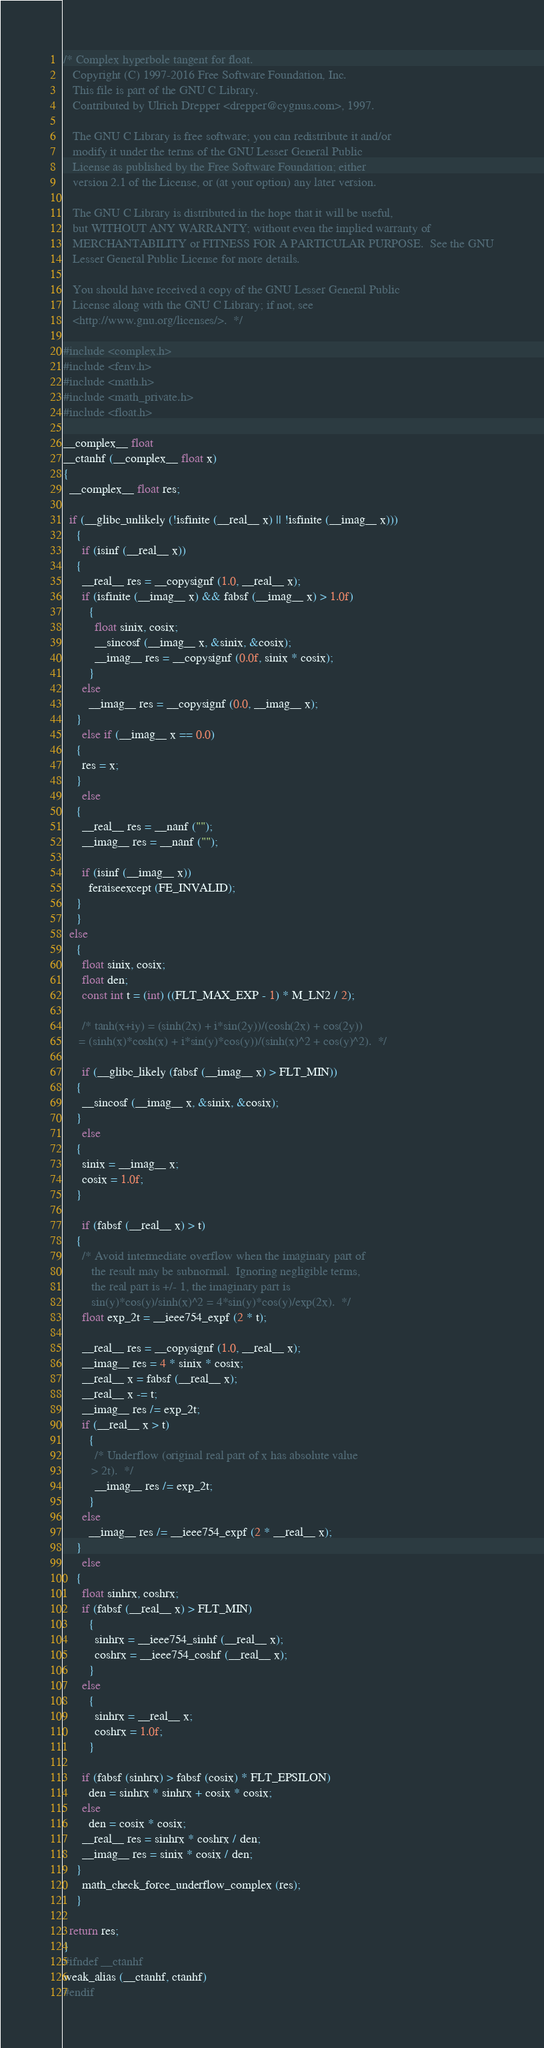Convert code to text. <code><loc_0><loc_0><loc_500><loc_500><_C_>/* Complex hyperbole tangent for float.
   Copyright (C) 1997-2016 Free Software Foundation, Inc.
   This file is part of the GNU C Library.
   Contributed by Ulrich Drepper <drepper@cygnus.com>, 1997.

   The GNU C Library is free software; you can redistribute it and/or
   modify it under the terms of the GNU Lesser General Public
   License as published by the Free Software Foundation; either
   version 2.1 of the License, or (at your option) any later version.

   The GNU C Library is distributed in the hope that it will be useful,
   but WITHOUT ANY WARRANTY; without even the implied warranty of
   MERCHANTABILITY or FITNESS FOR A PARTICULAR PURPOSE.  See the GNU
   Lesser General Public License for more details.

   You should have received a copy of the GNU Lesser General Public
   License along with the GNU C Library; if not, see
   <http://www.gnu.org/licenses/>.  */

#include <complex.h>
#include <fenv.h>
#include <math.h>
#include <math_private.h>
#include <float.h>

__complex__ float
__ctanhf (__complex__ float x)
{
  __complex__ float res;

  if (__glibc_unlikely (!isfinite (__real__ x) || !isfinite (__imag__ x)))
    {
      if (isinf (__real__ x))
	{
	  __real__ res = __copysignf (1.0, __real__ x);
	  if (isfinite (__imag__ x) && fabsf (__imag__ x) > 1.0f)
	    {
	      float sinix, cosix;
	      __sincosf (__imag__ x, &sinix, &cosix);
	      __imag__ res = __copysignf (0.0f, sinix * cosix);
	    }
	  else
	    __imag__ res = __copysignf (0.0, __imag__ x);
	}
      else if (__imag__ x == 0.0)
	{
	  res = x;
	}
      else
	{
	  __real__ res = __nanf ("");
	  __imag__ res = __nanf ("");

	  if (isinf (__imag__ x))
	    feraiseexcept (FE_INVALID);
	}
    }
  else
    {
      float sinix, cosix;
      float den;
      const int t = (int) ((FLT_MAX_EXP - 1) * M_LN2 / 2);

      /* tanh(x+iy) = (sinh(2x) + i*sin(2y))/(cosh(2x) + cos(2y))
	 = (sinh(x)*cosh(x) + i*sin(y)*cos(y))/(sinh(x)^2 + cos(y)^2).  */

      if (__glibc_likely (fabsf (__imag__ x) > FLT_MIN))
	{
	  __sincosf (__imag__ x, &sinix, &cosix);
	}
      else
	{
	  sinix = __imag__ x;
	  cosix = 1.0f;
	}

      if (fabsf (__real__ x) > t)
	{
	  /* Avoid intermediate overflow when the imaginary part of
	     the result may be subnormal.  Ignoring negligible terms,
	     the real part is +/- 1, the imaginary part is
	     sin(y)*cos(y)/sinh(x)^2 = 4*sin(y)*cos(y)/exp(2x).  */
	  float exp_2t = __ieee754_expf (2 * t);

	  __real__ res = __copysignf (1.0, __real__ x);
	  __imag__ res = 4 * sinix * cosix;
	  __real__ x = fabsf (__real__ x);
	  __real__ x -= t;
	  __imag__ res /= exp_2t;
	  if (__real__ x > t)
	    {
	      /* Underflow (original real part of x has absolute value
		 > 2t).  */
	      __imag__ res /= exp_2t;
	    }
	  else
	    __imag__ res /= __ieee754_expf (2 * __real__ x);
	}
      else
	{
	  float sinhrx, coshrx;
	  if (fabsf (__real__ x) > FLT_MIN)
	    {
	      sinhrx = __ieee754_sinhf (__real__ x);
	      coshrx = __ieee754_coshf (__real__ x);
	    }
	  else
	    {
	      sinhrx = __real__ x;
	      coshrx = 1.0f;
	    }

	  if (fabsf (sinhrx) > fabsf (cosix) * FLT_EPSILON)
	    den = sinhrx * sinhrx + cosix * cosix;
	  else
	    den = cosix * cosix;
	  __real__ res = sinhrx * coshrx / den;
	  __imag__ res = sinix * cosix / den;
	}
      math_check_force_underflow_complex (res);
    }

  return res;
}
#ifndef __ctanhf
weak_alias (__ctanhf, ctanhf)
#endif
</code> 